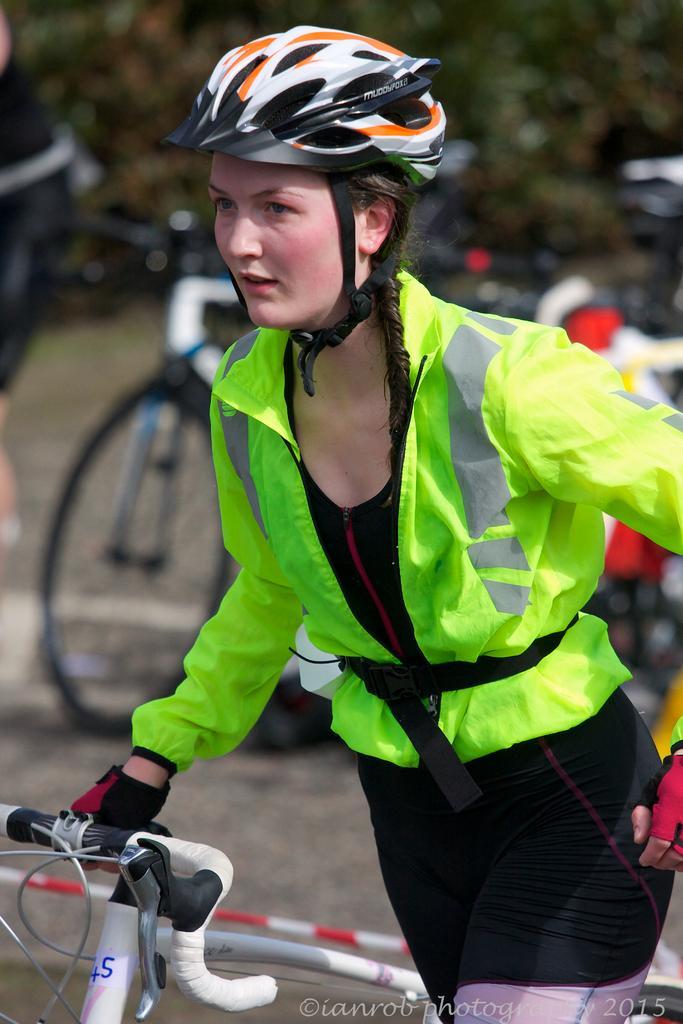In one or two sentences, can you explain what this image depicts? In this image there is one women standing and holding to a bicycle in middle of this image and there is a watermark at bottom of this image and there are some other bicycles in the background and there are some trees at top of this image. 